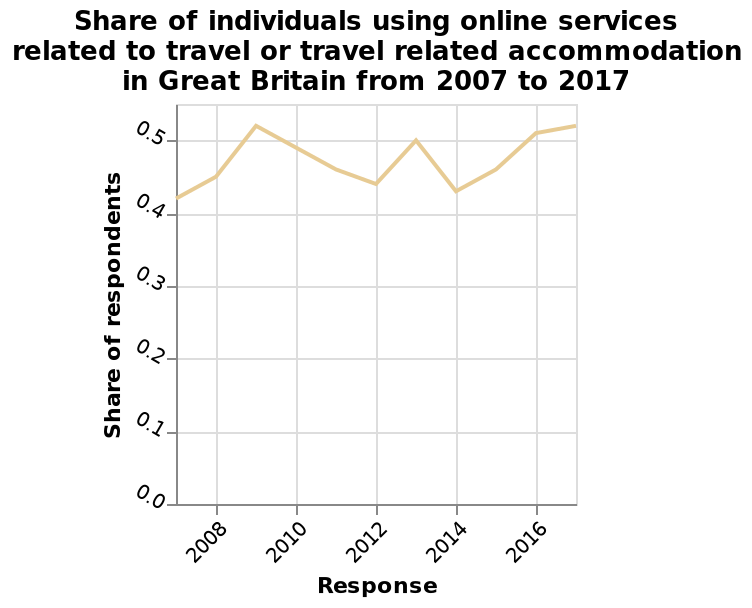<image>
What is the overall trend in the share of individuals using online services related to travel or travel related accommodation?  The overall trend in the share of individuals using online services related to travel or travel related accommodation has increased by 0.1 during the period. What is the title of the line plot? The title of the line plot is "Share of individuals using online services related to travel or travel-related accommodation in Great Britain from 2007 to 2017." What does the y-axis measure on the line plot? The y-axis measures the share of respondents using online services related to travel or travel-related accommodation. 